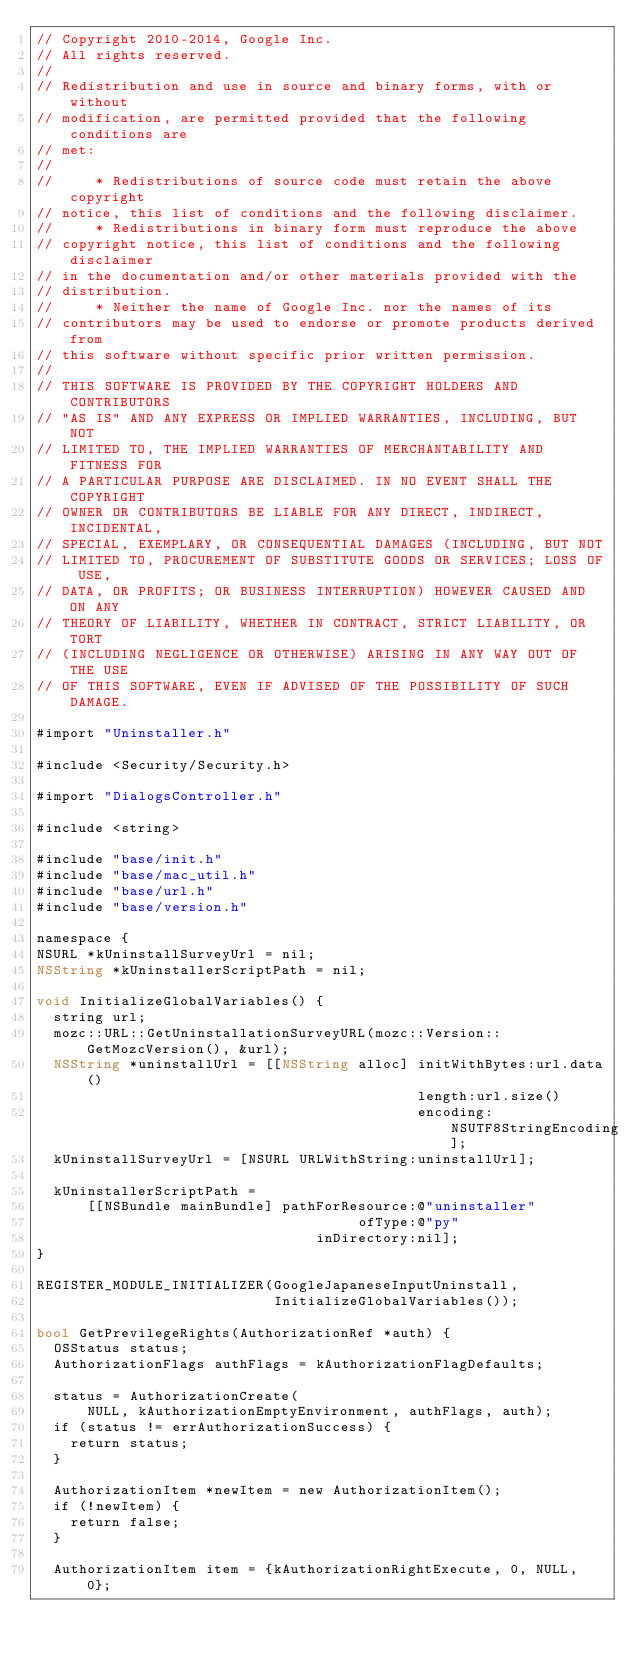<code> <loc_0><loc_0><loc_500><loc_500><_ObjectiveC_>// Copyright 2010-2014, Google Inc.
// All rights reserved.
//
// Redistribution and use in source and binary forms, with or without
// modification, are permitted provided that the following conditions are
// met:
//
//     * Redistributions of source code must retain the above copyright
// notice, this list of conditions and the following disclaimer.
//     * Redistributions in binary form must reproduce the above
// copyright notice, this list of conditions and the following disclaimer
// in the documentation and/or other materials provided with the
// distribution.
//     * Neither the name of Google Inc. nor the names of its
// contributors may be used to endorse or promote products derived from
// this software without specific prior written permission.
//
// THIS SOFTWARE IS PROVIDED BY THE COPYRIGHT HOLDERS AND CONTRIBUTORS
// "AS IS" AND ANY EXPRESS OR IMPLIED WARRANTIES, INCLUDING, BUT NOT
// LIMITED TO, THE IMPLIED WARRANTIES OF MERCHANTABILITY AND FITNESS FOR
// A PARTICULAR PURPOSE ARE DISCLAIMED. IN NO EVENT SHALL THE COPYRIGHT
// OWNER OR CONTRIBUTORS BE LIABLE FOR ANY DIRECT, INDIRECT, INCIDENTAL,
// SPECIAL, EXEMPLARY, OR CONSEQUENTIAL DAMAGES (INCLUDING, BUT NOT
// LIMITED TO, PROCUREMENT OF SUBSTITUTE GOODS OR SERVICES; LOSS OF USE,
// DATA, OR PROFITS; OR BUSINESS INTERRUPTION) HOWEVER CAUSED AND ON ANY
// THEORY OF LIABILITY, WHETHER IN CONTRACT, STRICT LIABILITY, OR TORT
// (INCLUDING NEGLIGENCE OR OTHERWISE) ARISING IN ANY WAY OUT OF THE USE
// OF THIS SOFTWARE, EVEN IF ADVISED OF THE POSSIBILITY OF SUCH DAMAGE.

#import "Uninstaller.h"

#include <Security/Security.h>

#import "DialogsController.h"

#include <string>

#include "base/init.h"
#include "base/mac_util.h"
#include "base/url.h"
#include "base/version.h"

namespace {
NSURL *kUninstallSurveyUrl = nil;
NSString *kUninstallerScriptPath = nil;

void InitializeGlobalVariables() {
  string url;
  mozc::URL::GetUninstallationSurveyURL(mozc::Version::GetMozcVersion(), &url);
  NSString *uninstallUrl = [[NSString alloc] initWithBytes:url.data()
                                             length:url.size()
                                             encoding:NSUTF8StringEncoding];
  kUninstallSurveyUrl = [NSURL URLWithString:uninstallUrl];

  kUninstallerScriptPath =
      [[NSBundle mainBundle] pathForResource:@"uninstaller"
                                      ofType:@"py"
                                 inDirectory:nil];
}

REGISTER_MODULE_INITIALIZER(GoogleJapaneseInputUninstall,
                            InitializeGlobalVariables());

bool GetPrevilegeRights(AuthorizationRef *auth) {
  OSStatus status;
  AuthorizationFlags authFlags = kAuthorizationFlagDefaults;

  status = AuthorizationCreate(
      NULL, kAuthorizationEmptyEnvironment, authFlags, auth);
  if (status != errAuthorizationSuccess) {
    return status;
  }

  AuthorizationItem *newItem = new AuthorizationItem();
  if (!newItem) {
    return false;
  }

  AuthorizationItem item = {kAuthorizationRightExecute, 0, NULL, 0};</code> 